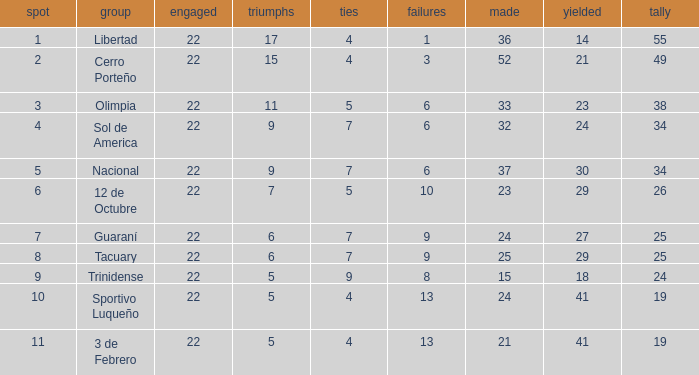What was the number of losses when the scored value was 25? 9.0. Parse the full table. {'header': ['spot', 'group', 'engaged', 'triumphs', 'ties', 'failures', 'made', 'yielded', 'tally'], 'rows': [['1', 'Libertad', '22', '17', '4', '1', '36', '14', '55'], ['2', 'Cerro Porteño', '22', '15', '4', '3', '52', '21', '49'], ['3', 'Olimpia', '22', '11', '5', '6', '33', '23', '38'], ['4', 'Sol de America', '22', '9', '7', '6', '32', '24', '34'], ['5', 'Nacional', '22', '9', '7', '6', '37', '30', '34'], ['6', '12 de Octubre', '22', '7', '5', '10', '23', '29', '26'], ['7', 'Guaraní', '22', '6', '7', '9', '24', '27', '25'], ['8', 'Tacuary', '22', '6', '7', '9', '25', '29', '25'], ['9', 'Trinidense', '22', '5', '9', '8', '15', '18', '24'], ['10', 'Sportivo Luqueño', '22', '5', '4', '13', '24', '41', '19'], ['11', '3 de Febrero', '22', '5', '4', '13', '21', '41', '19']]} 